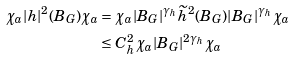Convert formula to latex. <formula><loc_0><loc_0><loc_500><loc_500>\chi _ { a } | h | ^ { 2 } ( B _ { G } ) \chi _ { a } & = \chi _ { a } | B _ { G } | ^ { \gamma _ { h } } \widetilde { h } ^ { 2 } ( B _ { G } ) | B _ { G } | ^ { \gamma _ { h } } \chi _ { a } \\ & \leq C _ { h } ^ { 2 } \chi _ { a } | B _ { G } | ^ { 2 \gamma _ { h } } \chi _ { a }</formula> 